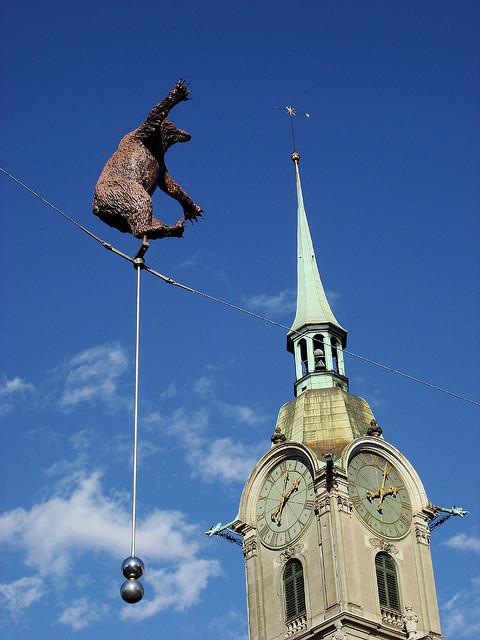In which direction is the bear seen here currently moving? right 